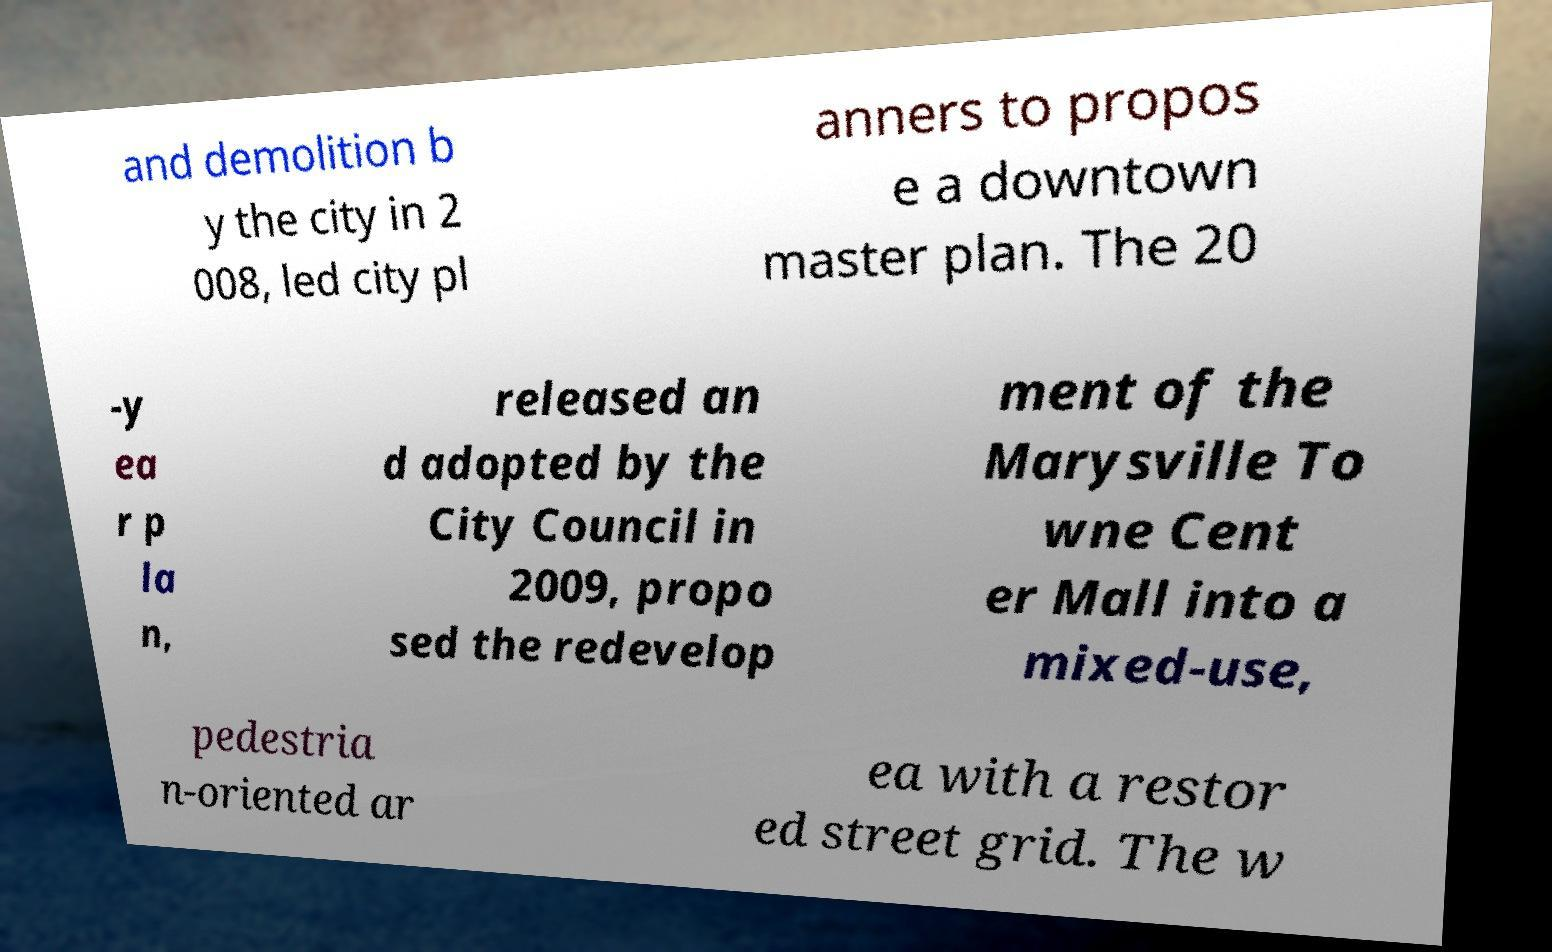I need the written content from this picture converted into text. Can you do that? and demolition b y the city in 2 008, led city pl anners to propos e a downtown master plan. The 20 -y ea r p la n, released an d adopted by the City Council in 2009, propo sed the redevelop ment of the Marysville To wne Cent er Mall into a mixed-use, pedestria n-oriented ar ea with a restor ed street grid. The w 